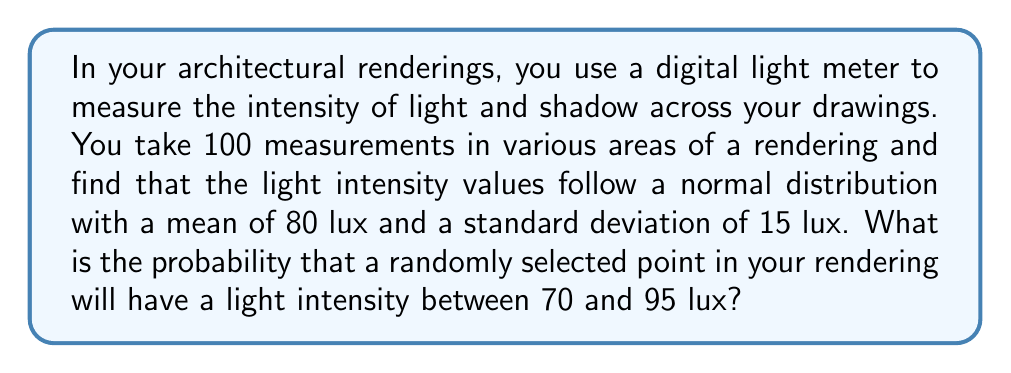What is the answer to this math problem? To solve this problem, we need to use the properties of the normal distribution and the concept of z-scores.

1. Given information:
   - The light intensity follows a normal distribution
   - Mean (μ) = 80 lux
   - Standard deviation (σ) = 15 lux
   - We want to find P(70 < X < 95), where X is the light intensity

2. Convert the given values to z-scores:
   For the lower bound: $z_1 = \frac{70 - 80}{15} = -\frac{2}{3} \approx -0.6667$
   For the upper bound: $z_2 = \frac{95 - 80}{15} = 1$

3. Use the standard normal distribution table or a calculator to find the area under the curve between these z-scores:
   P(70 < X < 95) = P(-0.6667 < Z < 1)
                  = P(Z < 1) - P(Z < -0.6667)

4. Looking up these values in a standard normal table or using a calculator:
   P(Z < 1) ≈ 0.8413
   P(Z < -0.6667) ≈ 0.2525

5. Calculate the final probability:
   P(70 < X < 95) = 0.8413 - 0.2525 = 0.5888

Therefore, the probability that a randomly selected point in your rendering will have a light intensity between 70 and 95 lux is approximately 0.5888 or 58.88%.
Answer: 0.5888 or 58.88% 